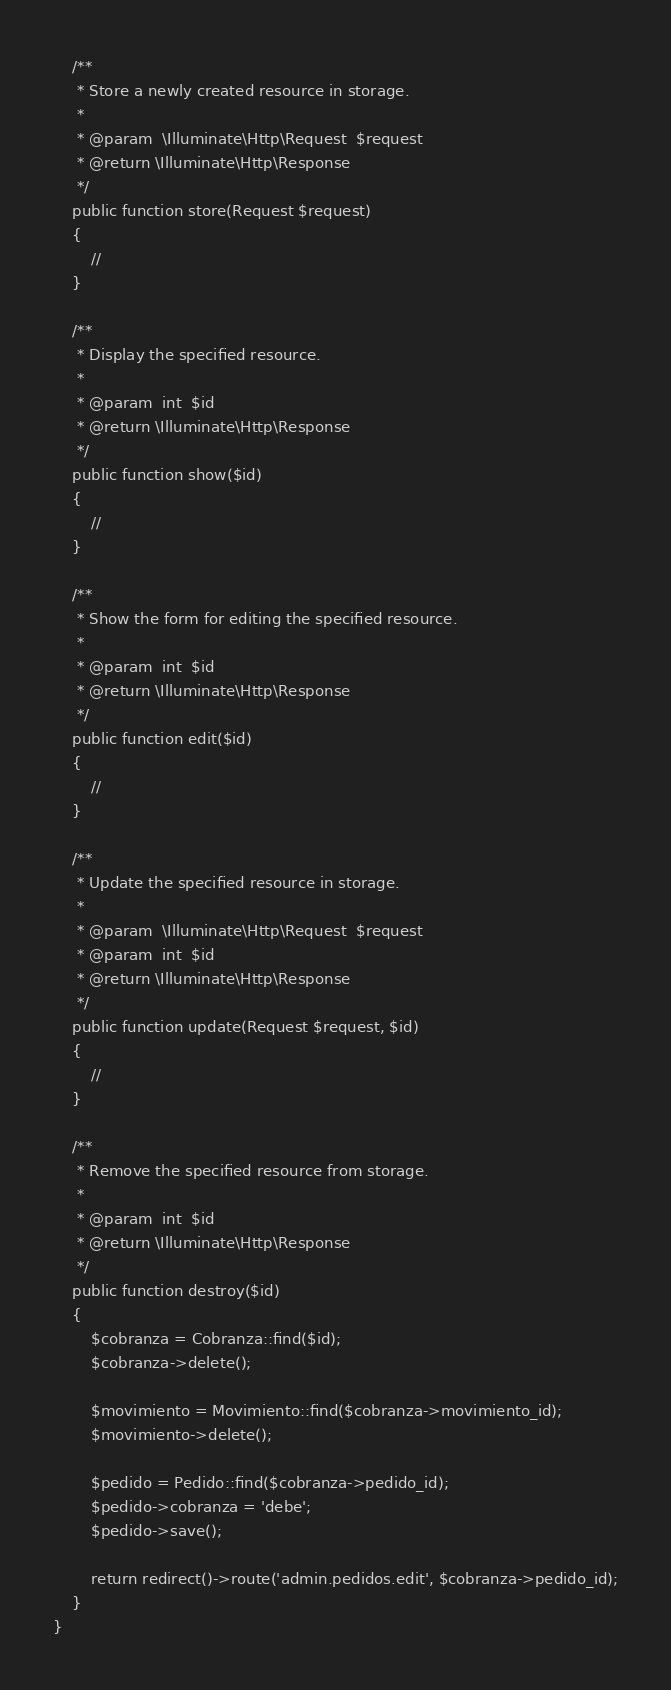<code> <loc_0><loc_0><loc_500><loc_500><_PHP_>    /**
     * Store a newly created resource in storage.
     *
     * @param  \Illuminate\Http\Request  $request
     * @return \Illuminate\Http\Response
     */
    public function store(Request $request)
    {
        //
    }

    /**
     * Display the specified resource.
     *
     * @param  int  $id
     * @return \Illuminate\Http\Response
     */
    public function show($id)
    {
        //
    }

    /**
     * Show the form for editing the specified resource.
     *
     * @param  int  $id
     * @return \Illuminate\Http\Response
     */
    public function edit($id)
    {
        //
    }

    /**
     * Update the specified resource in storage.
     *
     * @param  \Illuminate\Http\Request  $request
     * @param  int  $id
     * @return \Illuminate\Http\Response
     */
    public function update(Request $request, $id)
    {
        //
    }

    /**
     * Remove the specified resource from storage.
     *
     * @param  int  $id
     * @return \Illuminate\Http\Response
     */
    public function destroy($id)
    {
        $cobranza = Cobranza::find($id);
        $cobranza->delete();

        $movimiento = Movimiento::find($cobranza->movimiento_id);
        $movimiento->delete();

        $pedido = Pedido::find($cobranza->pedido_id);
        $pedido->cobranza = 'debe';
        $pedido->save();

        return redirect()->route('admin.pedidos.edit', $cobranza->pedido_id);
    }
}
</code> 